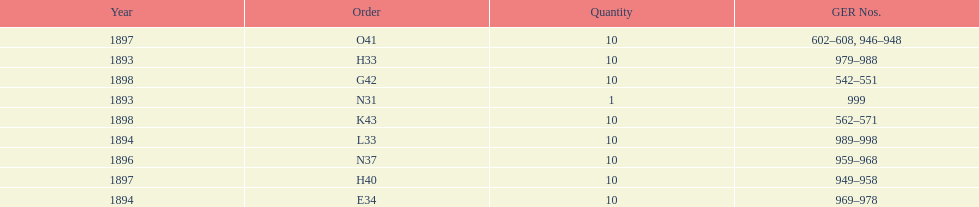How mans years have ger nos below 900? 2. 